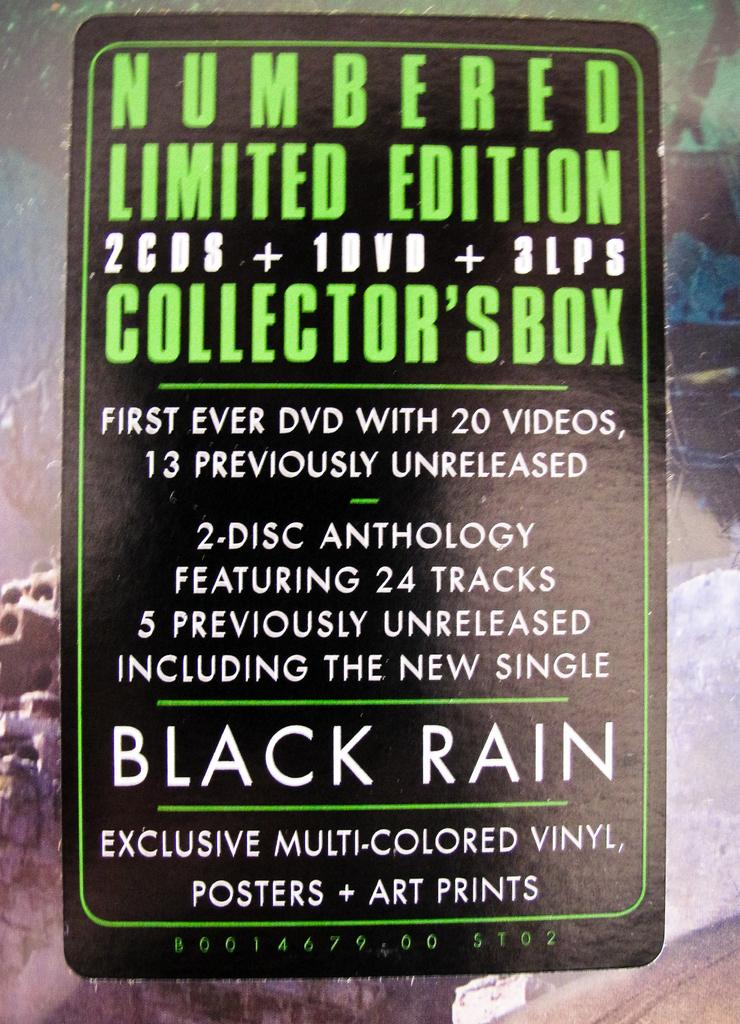What is the main subject of the image? There is an advertisement in the image. Can you describe the advertisement? Unfortunately, without more information, it is impossible to describe the advertisement in detail. What type of creature is telling a story in the image? There is no creature or story present in the image; it only contains an advertisement. 